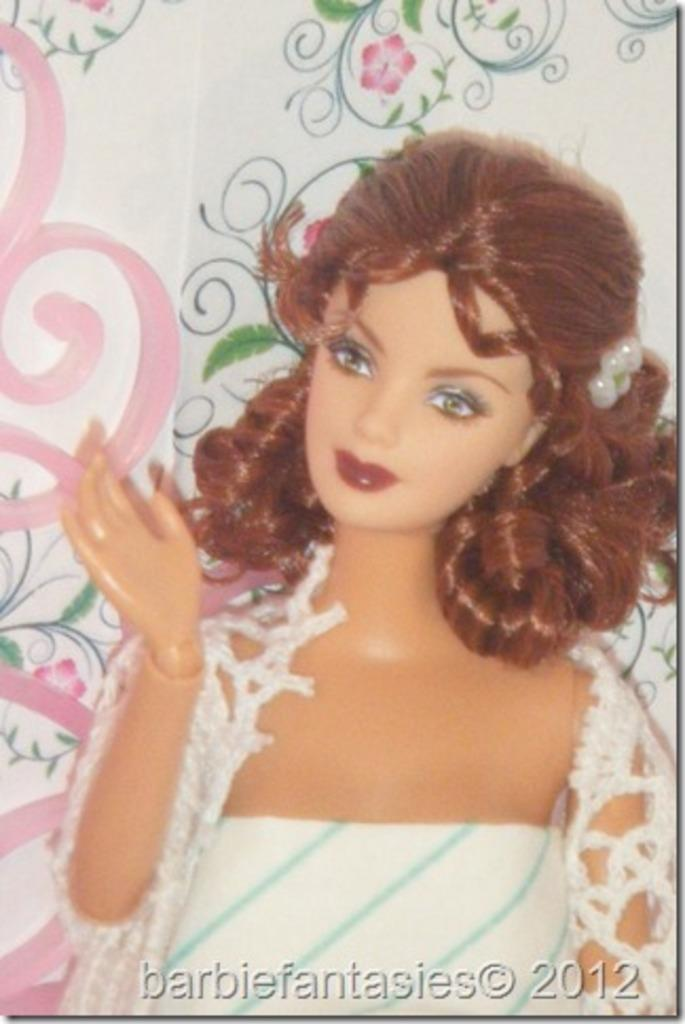What is the main object in the image? There is a banner in the image. What is depicted on the banner? The banner contains a drawing of a woman. What is the woman in the drawing wearing? The woman in the drawing is wearing a white dress. How many ducks are present in the image? There are no ducks present in the image; it only features a banner with a drawing of a woman. What type of muscle is visible in the drawing of the woman? There is no muscle visible in the drawing of the woman; it only shows her wearing a white dress. 